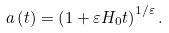Convert formula to latex. <formula><loc_0><loc_0><loc_500><loc_500>a \left ( t \right ) = \left ( 1 + \varepsilon H _ { 0 } t \right ) ^ { 1 / \varepsilon } .</formula> 